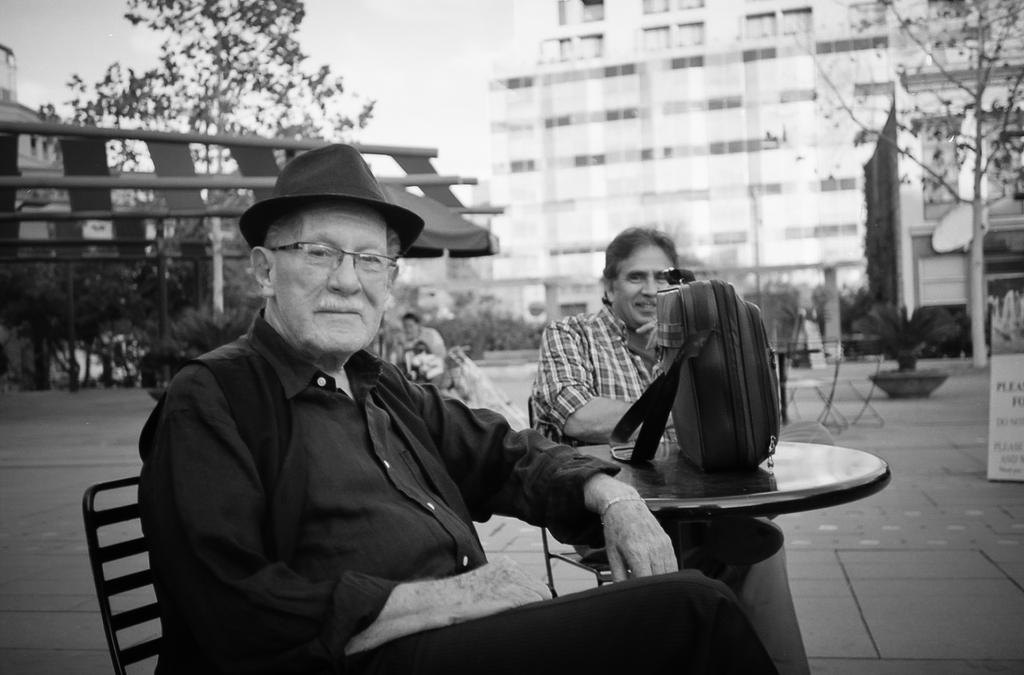How many people are sitting in the image? There are two people sitting on chairs in the image. What is on the table in the image? There is a bag on a table in the image. What can be seen in the background of the image? Buildings, trees, and a board are visible in the background of the image. What type of pickle is being used as a decoration on the board in the image? There is no pickle present in the image; it only features buildings, trees, and a board in the background. 